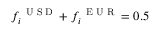Convert formula to latex. <formula><loc_0><loc_0><loc_500><loc_500>f _ { i } ^ { U S D } + f _ { i } ^ { E U R } = 0 . 5</formula> 